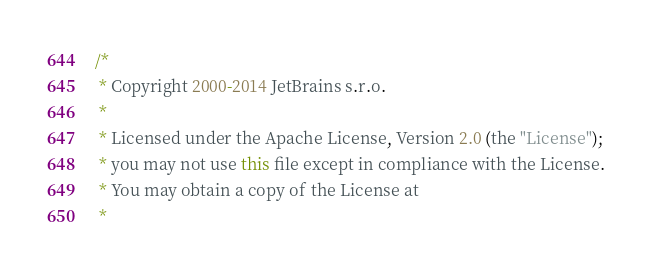<code> <loc_0><loc_0><loc_500><loc_500><_Java_>/*
 * Copyright 2000-2014 JetBrains s.r.o.
 *
 * Licensed under the Apache License, Version 2.0 (the "License");
 * you may not use this file except in compliance with the License.
 * You may obtain a copy of the License at
 *</code> 